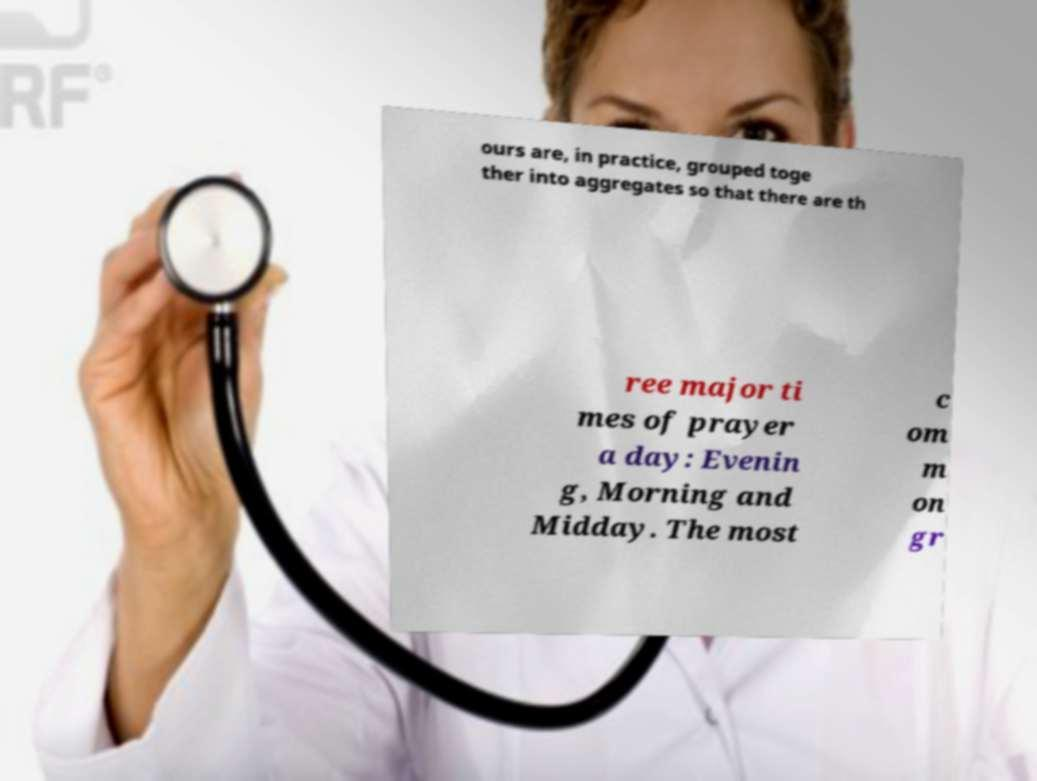Could you assist in decoding the text presented in this image and type it out clearly? ours are, in practice, grouped toge ther into aggregates so that there are th ree major ti mes of prayer a day: Evenin g, Morning and Midday. The most c om m on gr 